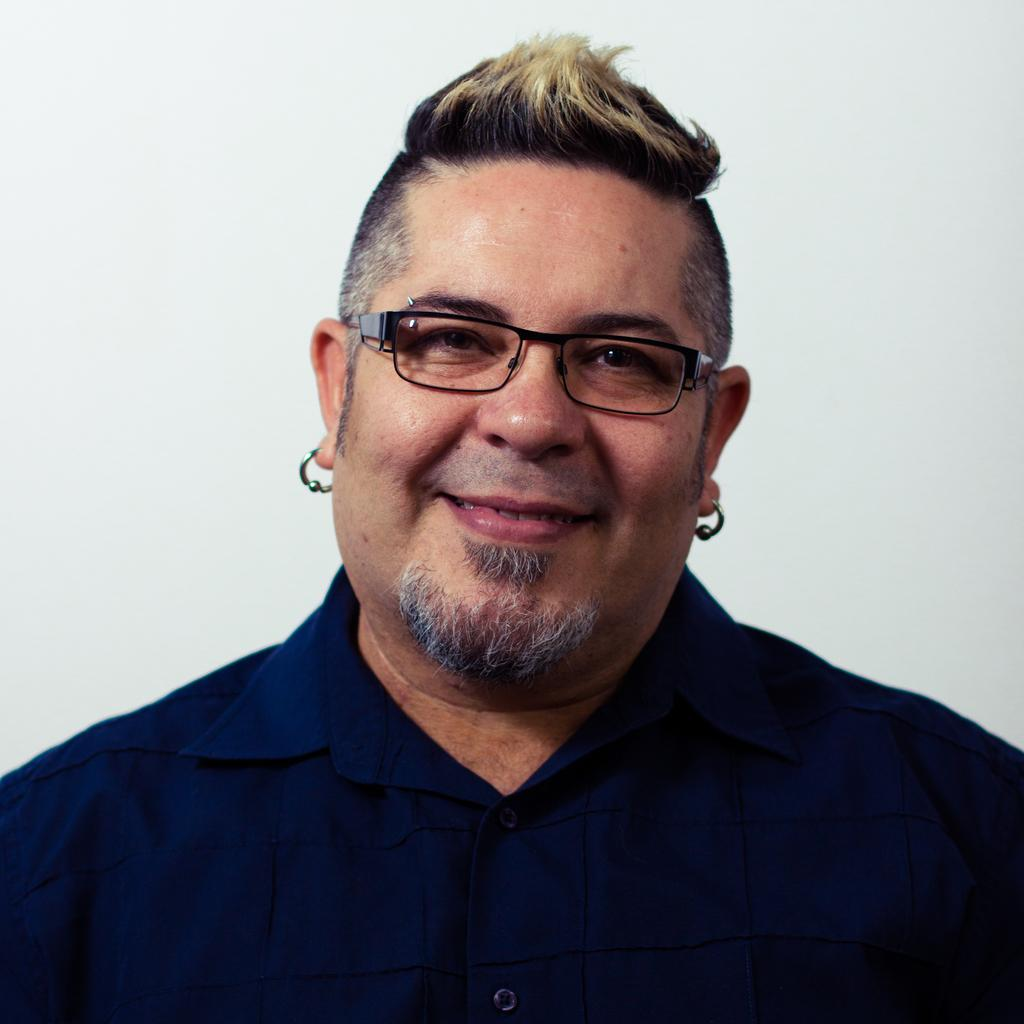What is the main subject of the image? There is a man in the image. What is the man wearing in the image? The man is wearing a dark blue shirt. What is the man's facial expression in the image? The man is smiling. What accessory is the man wearing in the image? The man is wearing spectacles. What is the color of the background in the image? The background of the image is white. What year is depicted in the image? There is no specific year depicted in the image; it is a photograph of a man wearing a dark blue shirt, smiling, and wearing spectacles against a white background. What sense is being stimulated by the slip in the image? There is no slip present in the image, so it is not possible to determine which sense might be stimulated. 